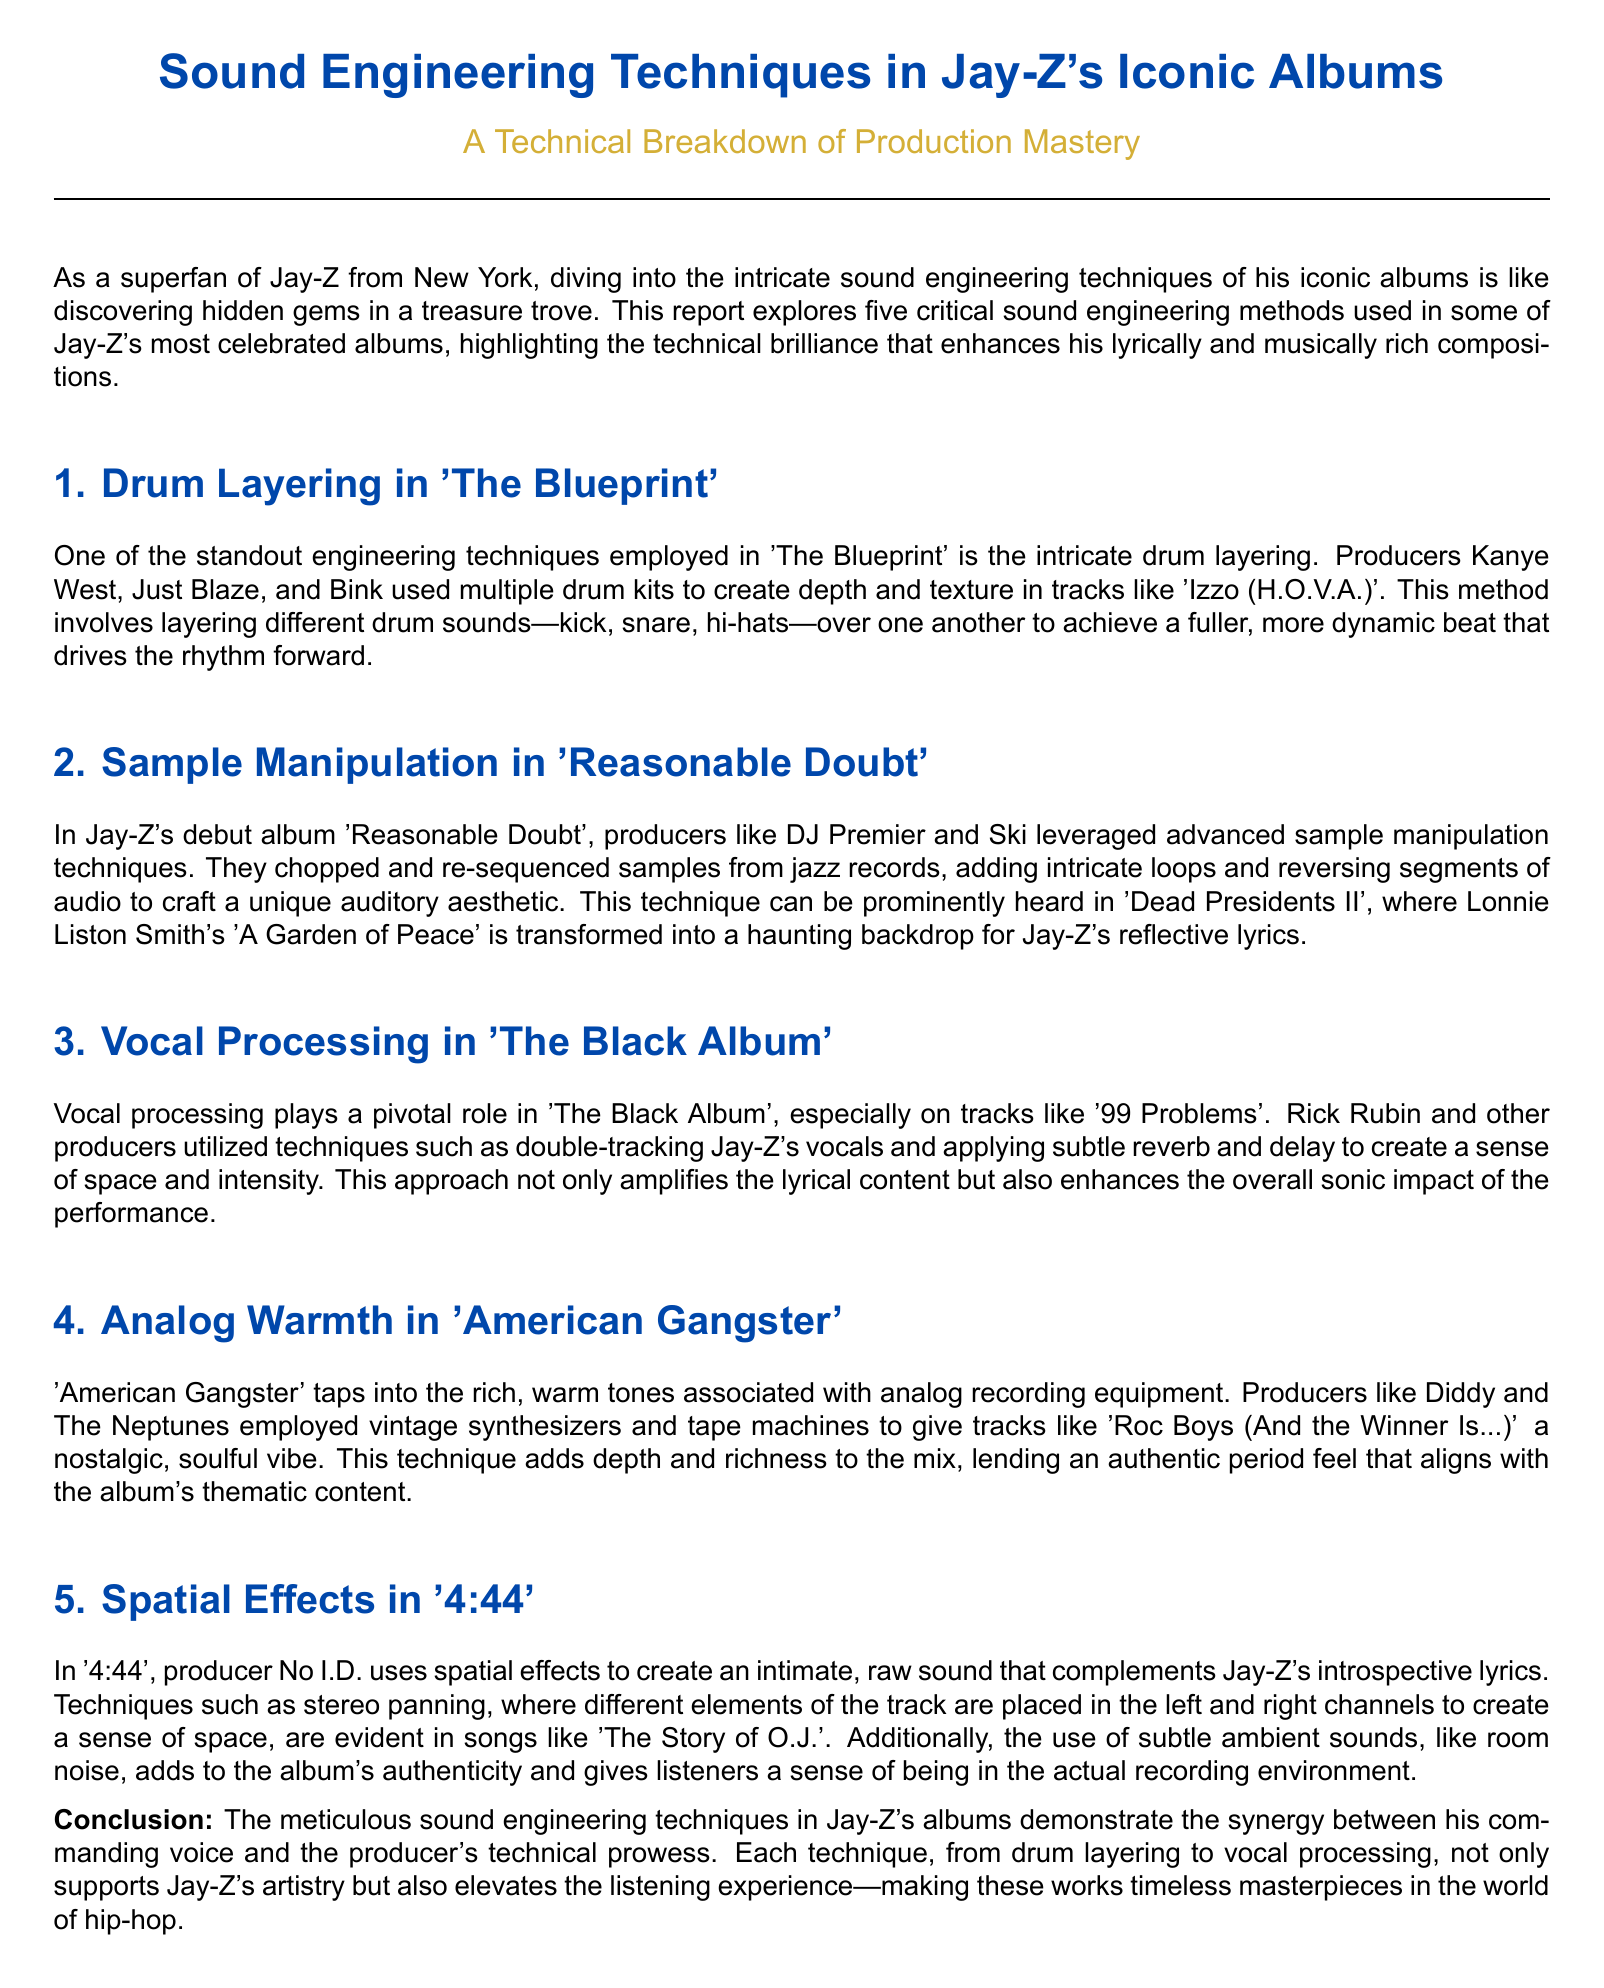What is the main focus of the report? The report explores the sound engineering techniques used in Jay-Z's iconic albums, highlighting technical brilliance.
Answer: Sound engineering techniques Who are the primary producers mentioned for 'The Blueprint'? Kanye West, Just Blaze, and Bink are the primary producers for 'The Blueprint'.
Answer: Kanye West, Just Blaze, and Bink What technique is predominantly used in 'Dead Presidents II'? The technique predominantly used in 'Dead Presidents II' is sample manipulation.
Answer: Sample manipulation Which album features the track '99 Problems'? The album with the track '99 Problems' is 'The Black Album'.
Answer: The Black Album What type of recording equipment is mentioned in 'American Gangster'? Vintage synthesizers and tape machines are types of recording equipment mentioned in 'American Gangster'.
Answer: Vintage synthesizers and tape machines How does No I.D. create an intimate sound in '4:44'? No I.D. uses spatial effects such as stereo panning to create an intimate sound in '4:44'.
Answer: Spatial effects What overarching theme do the sound engineering techniques support in Jay-Z's albums? The sound engineering techniques support Jay-Z's artistry and enhance the listening experience.
Answer: Jay-Z's artistry 